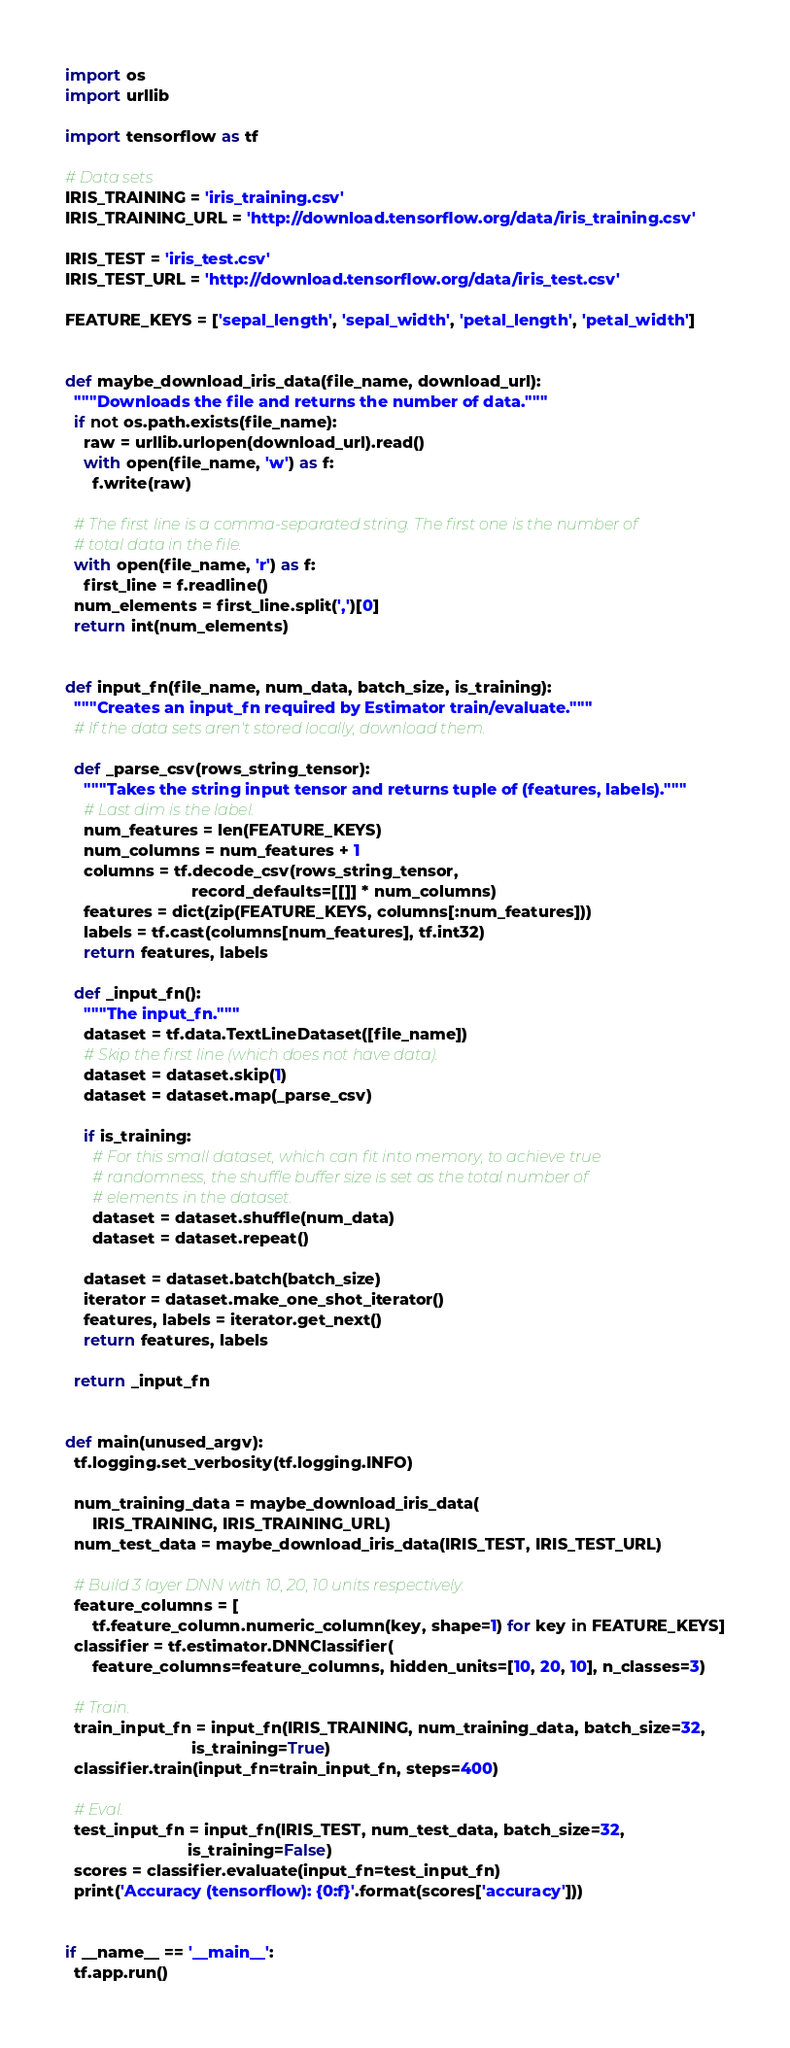Convert code to text. <code><loc_0><loc_0><loc_500><loc_500><_Python_>import os
import urllib

import tensorflow as tf

# Data sets
IRIS_TRAINING = 'iris_training.csv'
IRIS_TRAINING_URL = 'http://download.tensorflow.org/data/iris_training.csv'

IRIS_TEST = 'iris_test.csv'
IRIS_TEST_URL = 'http://download.tensorflow.org/data/iris_test.csv'

FEATURE_KEYS = ['sepal_length', 'sepal_width', 'petal_length', 'petal_width']


def maybe_download_iris_data(file_name, download_url):
  """Downloads the file and returns the number of data."""
  if not os.path.exists(file_name):
    raw = urllib.urlopen(download_url).read()
    with open(file_name, 'w') as f:
      f.write(raw)

  # The first line is a comma-separated string. The first one is the number of
  # total data in the file.
  with open(file_name, 'r') as f:
    first_line = f.readline()
  num_elements = first_line.split(',')[0]
  return int(num_elements)


def input_fn(file_name, num_data, batch_size, is_training):
  """Creates an input_fn required by Estimator train/evaluate."""
  # If the data sets aren't stored locally, download them.

  def _parse_csv(rows_string_tensor):
    """Takes the string input tensor and returns tuple of (features, labels)."""
    # Last dim is the label.
    num_features = len(FEATURE_KEYS)
    num_columns = num_features + 1
    columns = tf.decode_csv(rows_string_tensor,
                            record_defaults=[[]] * num_columns)
    features = dict(zip(FEATURE_KEYS, columns[:num_features]))
    labels = tf.cast(columns[num_features], tf.int32)
    return features, labels

  def _input_fn():
    """The input_fn."""
    dataset = tf.data.TextLineDataset([file_name])
    # Skip the first line (which does not have data).
    dataset = dataset.skip(1)
    dataset = dataset.map(_parse_csv)

    if is_training:
      # For this small dataset, which can fit into memory, to achieve true
      # randomness, the shuffle buffer size is set as the total number of
      # elements in the dataset.
      dataset = dataset.shuffle(num_data)
      dataset = dataset.repeat()

    dataset = dataset.batch(batch_size)
    iterator = dataset.make_one_shot_iterator()
    features, labels = iterator.get_next()
    return features, labels

  return _input_fn


def main(unused_argv):
  tf.logging.set_verbosity(tf.logging.INFO)

  num_training_data = maybe_download_iris_data(
      IRIS_TRAINING, IRIS_TRAINING_URL)
  num_test_data = maybe_download_iris_data(IRIS_TEST, IRIS_TEST_URL)

  # Build 3 layer DNN with 10, 20, 10 units respectively.
  feature_columns = [
      tf.feature_column.numeric_column(key, shape=1) for key in FEATURE_KEYS]
  classifier = tf.estimator.DNNClassifier(
      feature_columns=feature_columns, hidden_units=[10, 20, 10], n_classes=3)

  # Train.
  train_input_fn = input_fn(IRIS_TRAINING, num_training_data, batch_size=32,
                            is_training=True)
  classifier.train(input_fn=train_input_fn, steps=400)

  # Eval.
  test_input_fn = input_fn(IRIS_TEST, num_test_data, batch_size=32,
                           is_training=False)
  scores = classifier.evaluate(input_fn=test_input_fn)
  print('Accuracy (tensorflow): {0:f}'.format(scores['accuracy']))


if __name__ == '__main__':
  tf.app.run()
</code> 